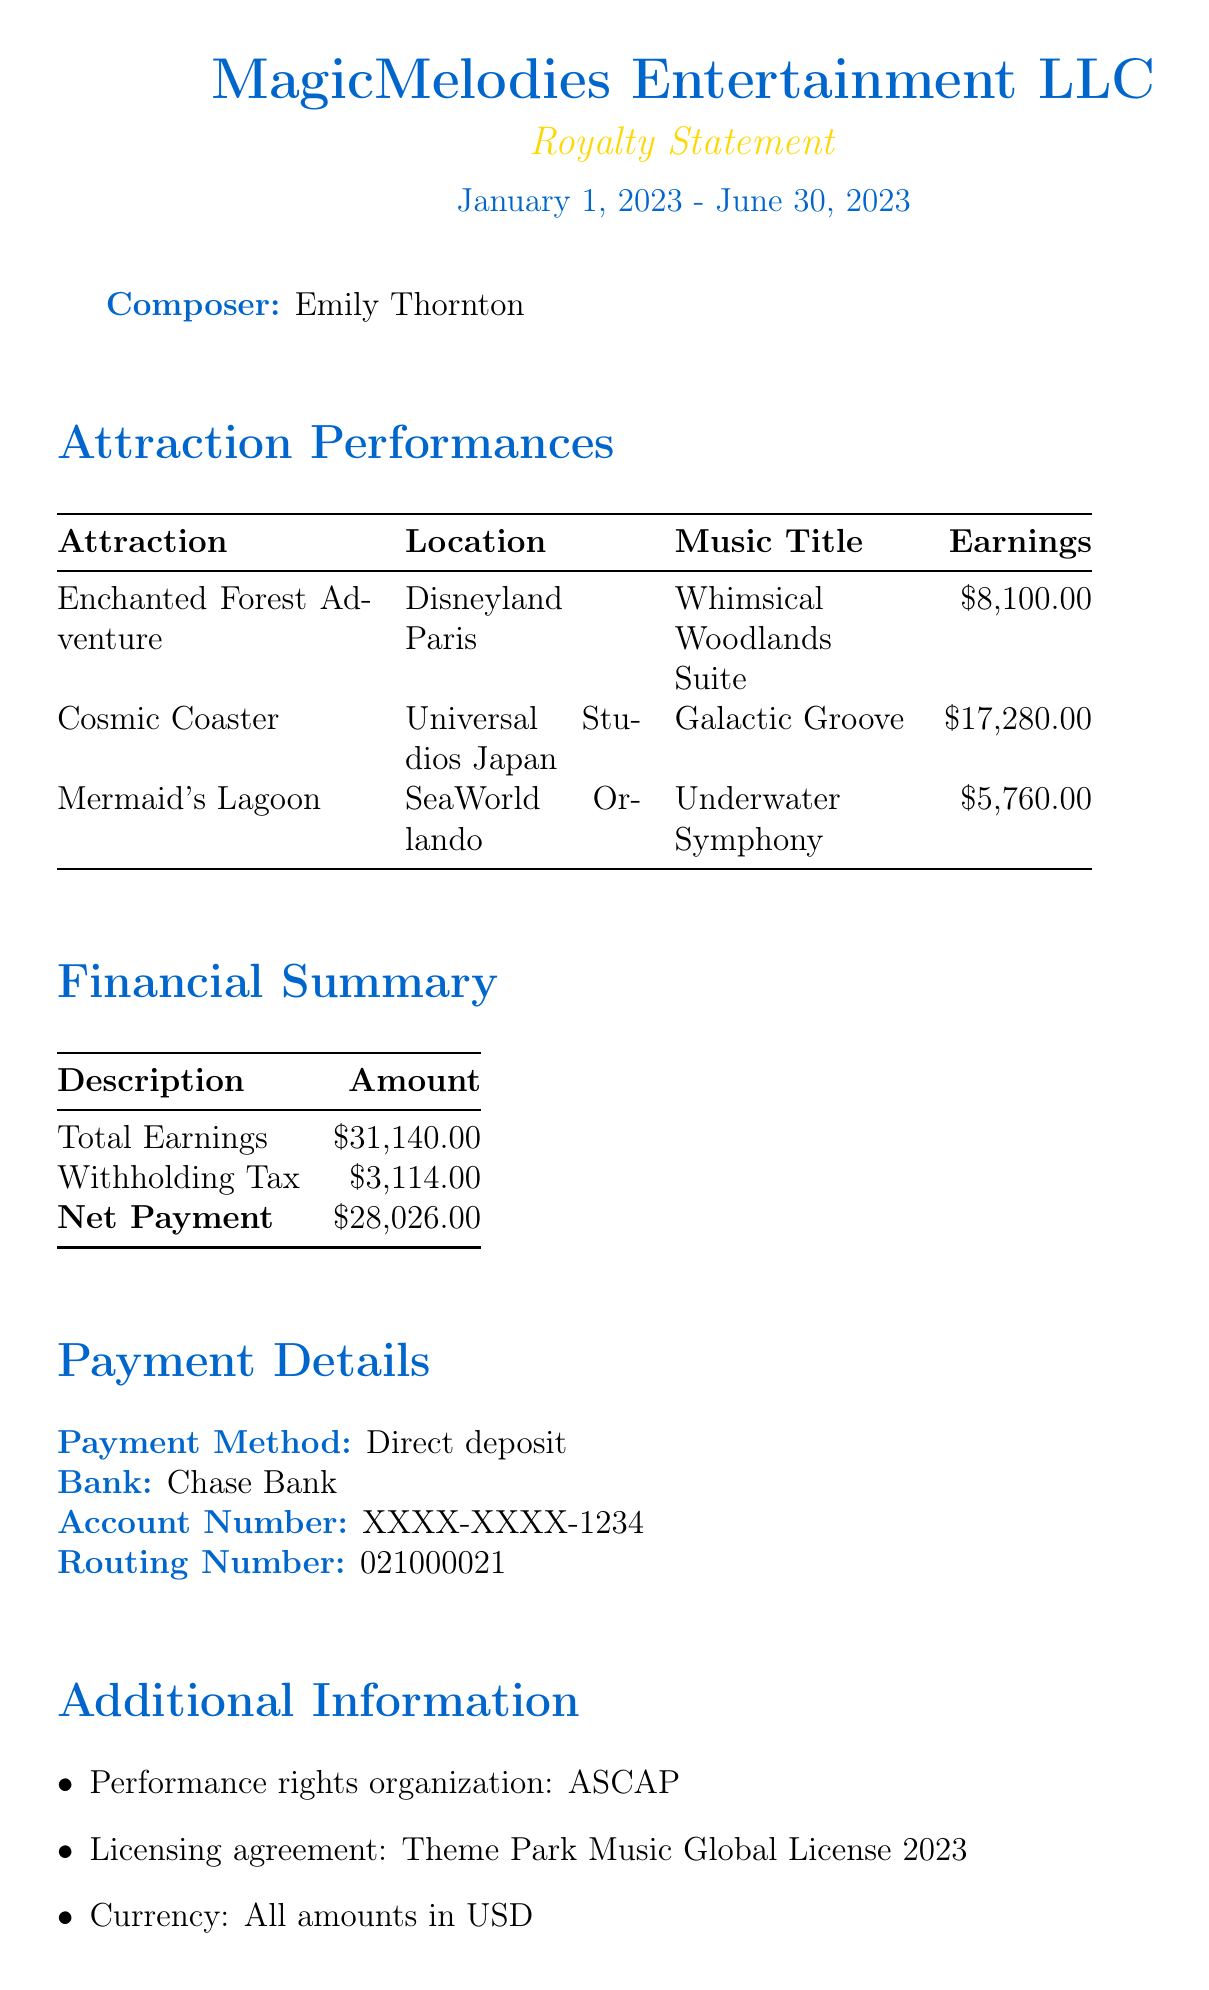what is the composer’s name? The document states the composer's name is Emily Thornton.
Answer: Emily Thornton what is the total earnings reported? The total earnings are indicated in the financial summary section of the document.
Answer: $31,140.00 how many plays did "Galactic Groove" have? The number of plays is specified for each music title in the document.
Answer: 5760 what is the royalty rate for "Underwater Symphony"? The royalty rate is provided for each music title in the earnings details.
Answer: 0.04 which theme park is "Rainforest Rapids" expected to launch at? The upcoming projects section lists the intended launch locations for future attractions.
Answer: Busch Gardens Tampa Bay how much was withheld as tax? The amount withheld for taxes is detailed in the financial summary.
Answer: $3,114.00 what is the expected launch quarter for "Pirate's Cove"? The document contains specific details about the expected launch dates of upcoming projects.
Answer: Q4 2023 who is the contact for royalties? The contact information section specifies the department responsible for royalties inquiries.
Answer: MagicMelodies Entertainment LLC what payment method is used for the royal payment? The payment method is explicitly mentioned in the document's payment details section.
Answer: Direct deposit 